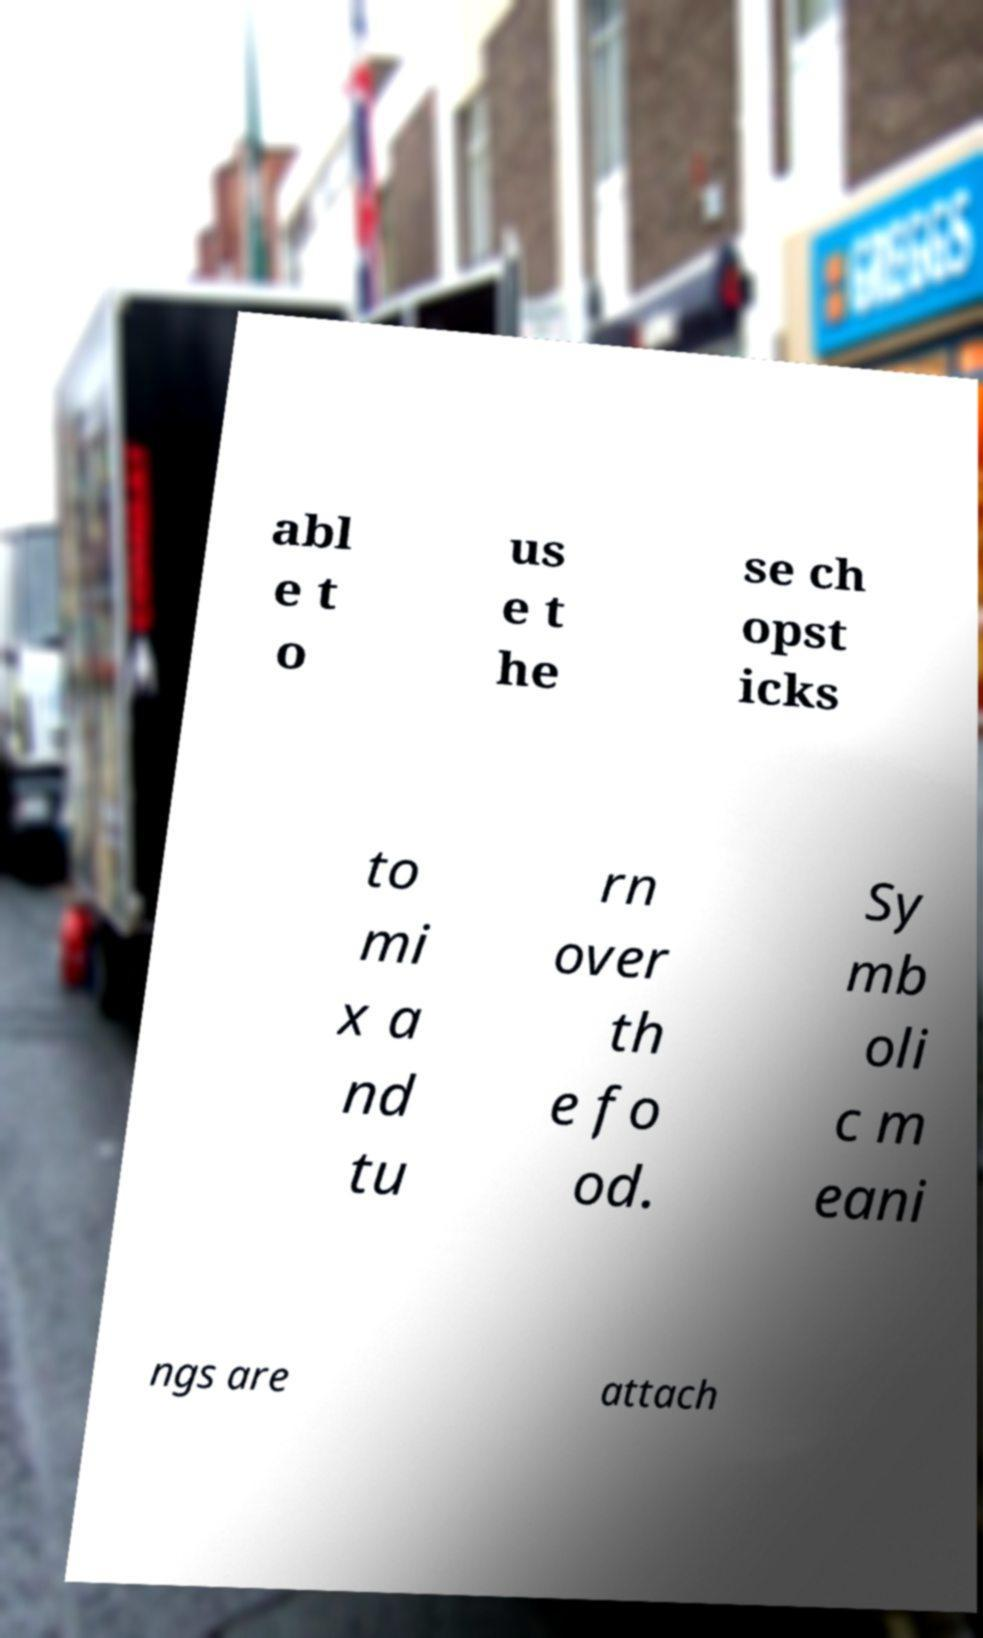Can you accurately transcribe the text from the provided image for me? abl e t o us e t he se ch opst icks to mi x a nd tu rn over th e fo od. Sy mb oli c m eani ngs are attach 